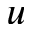<formula> <loc_0><loc_0><loc_500><loc_500>u</formula> 